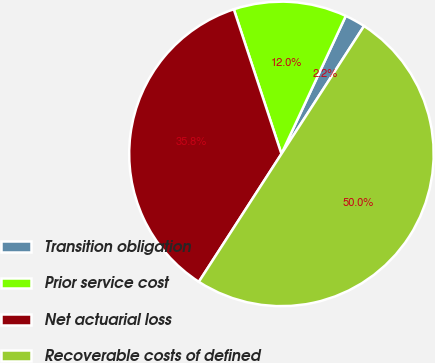Convert chart. <chart><loc_0><loc_0><loc_500><loc_500><pie_chart><fcel>Transition obligation<fcel>Prior service cost<fcel>Net actuarial loss<fcel>Recoverable costs of defined<nl><fcel>2.18%<fcel>12.01%<fcel>35.81%<fcel>50.0%<nl></chart> 